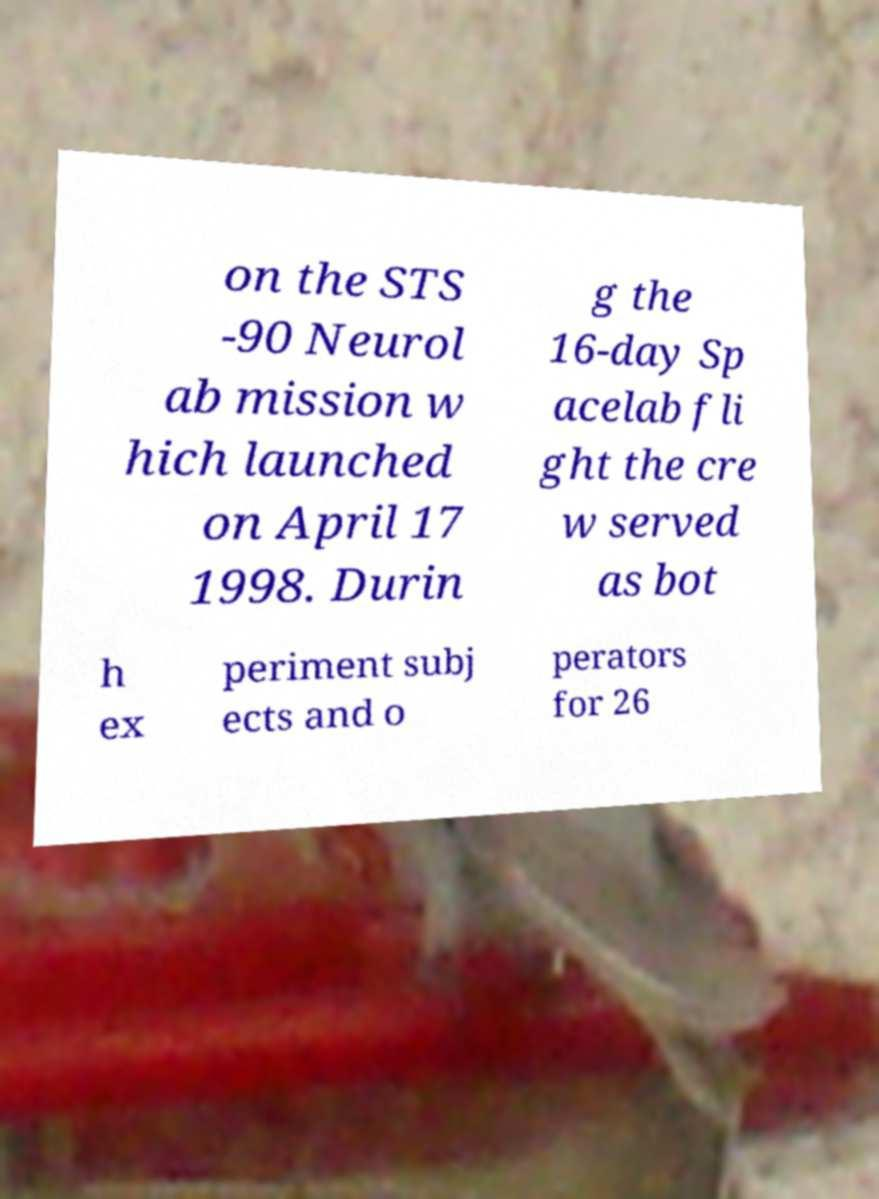Please read and relay the text visible in this image. What does it say? on the STS -90 Neurol ab mission w hich launched on April 17 1998. Durin g the 16-day Sp acelab fli ght the cre w served as bot h ex periment subj ects and o perators for 26 